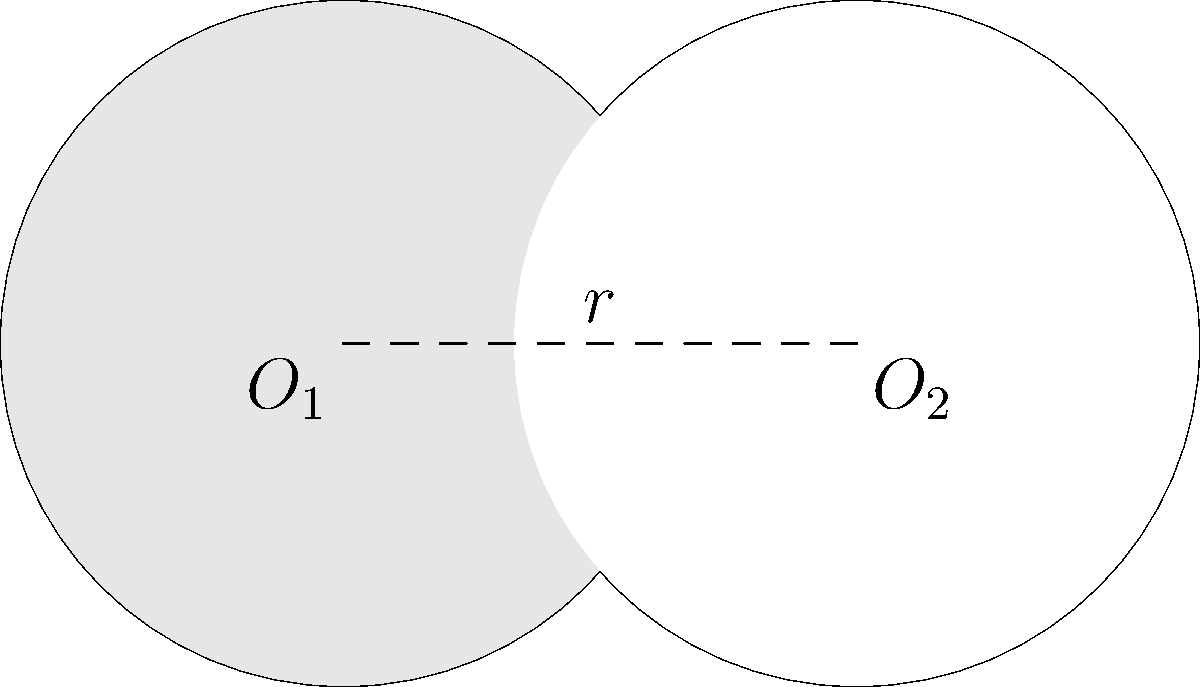Two circles with equal radii of 1 unit intersect as shown in the figure. The centers of the circles are 1.5 units apart. Calculate the area of the shaded region (lens-shaped area) formed by the overlapping circles. Let's approach this step-by-step:

1) First, we need to find the angle $\theta$ at the center of each circle that forms the lens-shaped region.

   Using the cosine rule in the triangle formed by the centers and a point of intersection:
   $\cos(\theta/2) = \frac{1.5}{2} = 0.75$

2) Therefore, $\theta/2 = \arccos(0.75) \approx 0.7227$ radians

3) The area of the lens-shaped region can be found by subtracting the area of two equal triangles from the area of two equal circular sectors:

   $A_{lens} = 2(A_{sector} - A_{triangle})$

4) Area of one sector: $A_{sector} = \frac{1}{2}r^2\theta = \frac{1}{2} \cdot 1^2 \cdot (2 \cdot 0.7227) = 0.7227$

5) Area of one triangle: $A_{triangle} = \frac{1}{2} \cdot 1 \cdot 1 \cdot \sin(0.7227) = 0.3307$

6) Therefore, the area of the lens-shaped region is:
   $A_{lens} = 2(0.7227 - 0.3307) = 2 \cdot 0.3920 = 0.7840$

Thus, the area of the shaded region is approximately 0.7840 square units.
Answer: $0.7840$ square units 